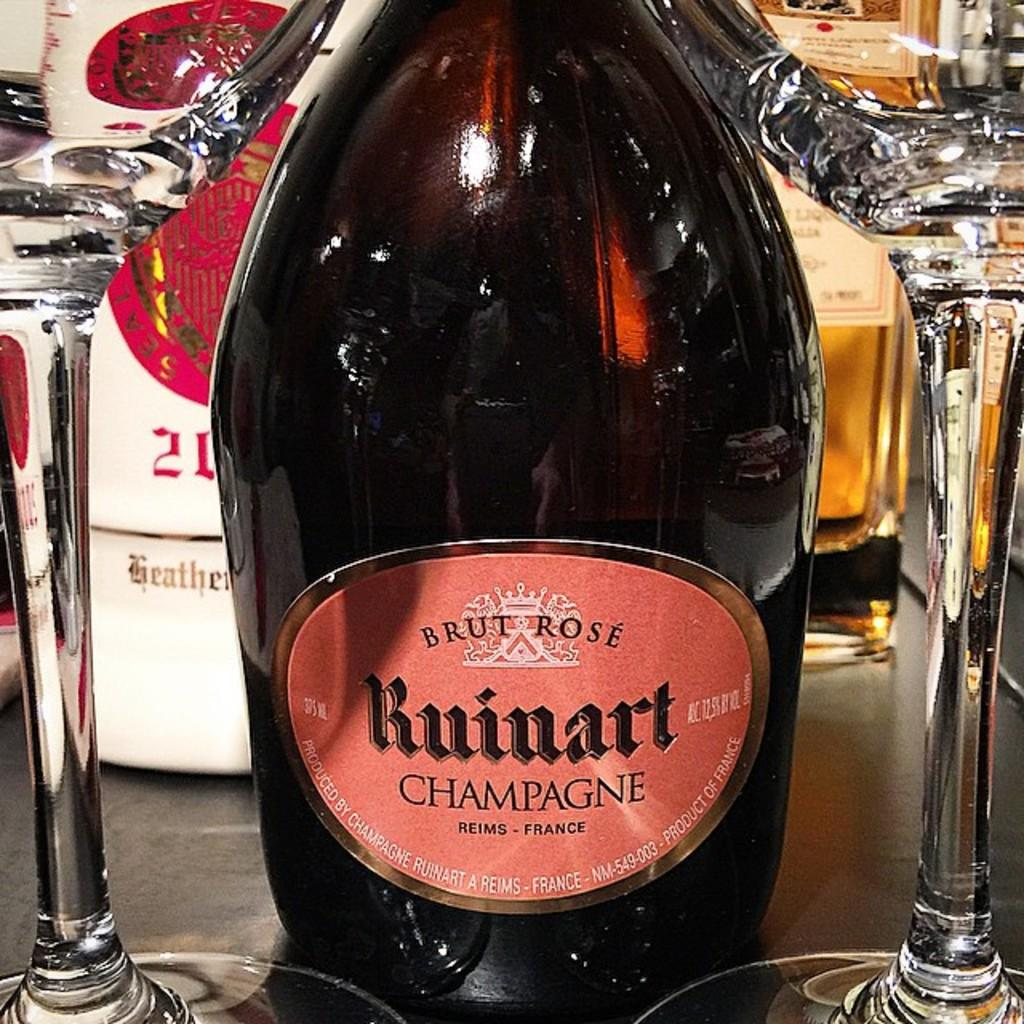<image>
Give a short and clear explanation of the subsequent image. A bottle of champagne with a red label that says Ruinart on it. 